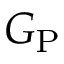<formula> <loc_0><loc_0><loc_500><loc_500>G _ { P }</formula> 